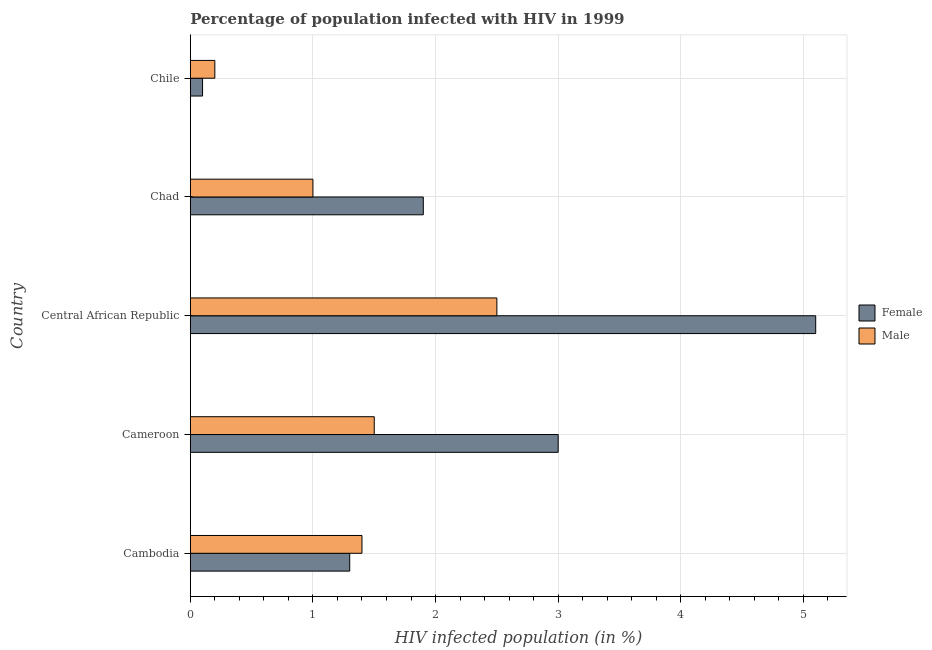How many different coloured bars are there?
Give a very brief answer. 2. How many groups of bars are there?
Your response must be concise. 5. Are the number of bars per tick equal to the number of legend labels?
Give a very brief answer. Yes. How many bars are there on the 1st tick from the top?
Your answer should be very brief. 2. How many bars are there on the 1st tick from the bottom?
Your answer should be very brief. 2. What is the label of the 5th group of bars from the top?
Your response must be concise. Cambodia. In how many cases, is the number of bars for a given country not equal to the number of legend labels?
Offer a terse response. 0. Across all countries, what is the maximum percentage of females who are infected with hiv?
Provide a succinct answer. 5.1. Across all countries, what is the minimum percentage of females who are infected with hiv?
Offer a terse response. 0.1. In which country was the percentage of females who are infected with hiv maximum?
Provide a succinct answer. Central African Republic. In which country was the percentage of females who are infected with hiv minimum?
Keep it short and to the point. Chile. What is the total percentage of males who are infected with hiv in the graph?
Offer a very short reply. 6.6. What is the difference between the percentage of females who are infected with hiv in Cameroon and that in Chile?
Provide a short and direct response. 2.9. What is the difference between the percentage of males who are infected with hiv in Cameroon and the percentage of females who are infected with hiv in Cambodia?
Give a very brief answer. 0.2. What is the average percentage of males who are infected with hiv per country?
Your answer should be compact. 1.32. In how many countries, is the percentage of females who are infected with hiv greater than 0.4 %?
Offer a very short reply. 4. What is the ratio of the percentage of females who are infected with hiv in Cambodia to that in Cameroon?
Your answer should be compact. 0.43. Is the percentage of males who are infected with hiv in Central African Republic less than that in Chile?
Provide a short and direct response. No. Is the difference between the percentage of males who are infected with hiv in Cameroon and Chile greater than the difference between the percentage of females who are infected with hiv in Cameroon and Chile?
Your answer should be very brief. No. What is the difference between the highest and the lowest percentage of females who are infected with hiv?
Provide a succinct answer. 5. In how many countries, is the percentage of males who are infected with hiv greater than the average percentage of males who are infected with hiv taken over all countries?
Ensure brevity in your answer.  3. What does the 2nd bar from the bottom in Cameroon represents?
Offer a very short reply. Male. How many bars are there?
Your answer should be very brief. 10. Does the graph contain grids?
Offer a terse response. Yes. How are the legend labels stacked?
Offer a terse response. Vertical. What is the title of the graph?
Offer a very short reply. Percentage of population infected with HIV in 1999. What is the label or title of the X-axis?
Your answer should be compact. HIV infected population (in %). What is the label or title of the Y-axis?
Your answer should be compact. Country. What is the HIV infected population (in %) of Female in Cambodia?
Make the answer very short. 1.3. What is the HIV infected population (in %) in Male in Cambodia?
Provide a short and direct response. 1.4. What is the HIV infected population (in %) of Male in Cameroon?
Offer a very short reply. 1.5. What is the HIV infected population (in %) in Female in Central African Republic?
Provide a succinct answer. 5.1. What is the HIV infected population (in %) of Female in Chad?
Keep it short and to the point. 1.9. What is the HIV infected population (in %) of Male in Chad?
Make the answer very short. 1. Across all countries, what is the maximum HIV infected population (in %) of Female?
Your answer should be very brief. 5.1. Across all countries, what is the minimum HIV infected population (in %) in Female?
Offer a terse response. 0.1. Across all countries, what is the minimum HIV infected population (in %) of Male?
Provide a succinct answer. 0.2. What is the difference between the HIV infected population (in %) in Female in Cambodia and that in Cameroon?
Keep it short and to the point. -1.7. What is the difference between the HIV infected population (in %) of Male in Cambodia and that in Cameroon?
Your answer should be very brief. -0.1. What is the difference between the HIV infected population (in %) in Female in Cambodia and that in Central African Republic?
Your response must be concise. -3.8. What is the difference between the HIV infected population (in %) of Female in Cambodia and that in Chad?
Make the answer very short. -0.6. What is the difference between the HIV infected population (in %) in Male in Cambodia and that in Chile?
Keep it short and to the point. 1.2. What is the difference between the HIV infected population (in %) in Female in Cameroon and that in Central African Republic?
Provide a succinct answer. -2.1. What is the difference between the HIV infected population (in %) in Male in Cameroon and that in Central African Republic?
Give a very brief answer. -1. What is the difference between the HIV infected population (in %) in Female in Cameroon and that in Chad?
Keep it short and to the point. 1.1. What is the difference between the HIV infected population (in %) in Female in Cameroon and that in Chile?
Your answer should be very brief. 2.9. What is the difference between the HIV infected population (in %) in Female in Central African Republic and that in Chad?
Keep it short and to the point. 3.2. What is the difference between the HIV infected population (in %) of Female in Central African Republic and that in Chile?
Make the answer very short. 5. What is the difference between the HIV infected population (in %) of Male in Central African Republic and that in Chile?
Give a very brief answer. 2.3. What is the difference between the HIV infected population (in %) in Female in Chad and that in Chile?
Your answer should be very brief. 1.8. What is the difference between the HIV infected population (in %) of Male in Chad and that in Chile?
Make the answer very short. 0.8. What is the difference between the HIV infected population (in %) of Female in Cambodia and the HIV infected population (in %) of Male in Central African Republic?
Keep it short and to the point. -1.2. What is the difference between the HIV infected population (in %) of Female in Cambodia and the HIV infected population (in %) of Male in Chad?
Your response must be concise. 0.3. What is the difference between the HIV infected population (in %) in Female in Cameroon and the HIV infected population (in %) in Male in Chad?
Offer a terse response. 2. What is the difference between the HIV infected population (in %) of Female in Central African Republic and the HIV infected population (in %) of Male in Chad?
Your answer should be very brief. 4.1. What is the difference between the HIV infected population (in %) of Female in Central African Republic and the HIV infected population (in %) of Male in Chile?
Offer a terse response. 4.9. What is the average HIV infected population (in %) of Female per country?
Offer a terse response. 2.28. What is the average HIV infected population (in %) of Male per country?
Offer a very short reply. 1.32. What is the difference between the HIV infected population (in %) of Female and HIV infected population (in %) of Male in Cambodia?
Provide a succinct answer. -0.1. What is the difference between the HIV infected population (in %) in Female and HIV infected population (in %) in Male in Central African Republic?
Offer a very short reply. 2.6. What is the difference between the HIV infected population (in %) of Female and HIV infected population (in %) of Male in Chile?
Give a very brief answer. -0.1. What is the ratio of the HIV infected population (in %) of Female in Cambodia to that in Cameroon?
Ensure brevity in your answer.  0.43. What is the ratio of the HIV infected population (in %) of Female in Cambodia to that in Central African Republic?
Your answer should be compact. 0.25. What is the ratio of the HIV infected population (in %) in Male in Cambodia to that in Central African Republic?
Provide a short and direct response. 0.56. What is the ratio of the HIV infected population (in %) of Female in Cambodia to that in Chad?
Your answer should be compact. 0.68. What is the ratio of the HIV infected population (in %) in Female in Cambodia to that in Chile?
Keep it short and to the point. 13. What is the ratio of the HIV infected population (in %) in Male in Cambodia to that in Chile?
Your answer should be very brief. 7. What is the ratio of the HIV infected population (in %) of Female in Cameroon to that in Central African Republic?
Give a very brief answer. 0.59. What is the ratio of the HIV infected population (in %) in Female in Cameroon to that in Chad?
Offer a terse response. 1.58. What is the ratio of the HIV infected population (in %) in Male in Cameroon to that in Chad?
Make the answer very short. 1.5. What is the ratio of the HIV infected population (in %) in Male in Cameroon to that in Chile?
Your response must be concise. 7.5. What is the ratio of the HIV infected population (in %) of Female in Central African Republic to that in Chad?
Make the answer very short. 2.68. What is the ratio of the HIV infected population (in %) in Male in Central African Republic to that in Chad?
Make the answer very short. 2.5. What is the ratio of the HIV infected population (in %) in Female in Central African Republic to that in Chile?
Offer a very short reply. 51. What is the ratio of the HIV infected population (in %) in Female in Chad to that in Chile?
Your answer should be compact. 19. What is the difference between the highest and the second highest HIV infected population (in %) in Female?
Your answer should be compact. 2.1. What is the difference between the highest and the lowest HIV infected population (in %) in Female?
Make the answer very short. 5. What is the difference between the highest and the lowest HIV infected population (in %) of Male?
Your response must be concise. 2.3. 